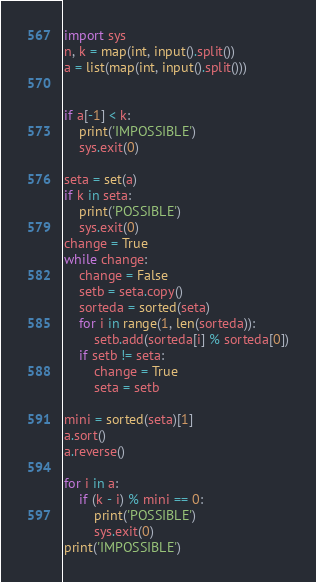Convert code to text. <code><loc_0><loc_0><loc_500><loc_500><_Python_>import sys
n, k = map(int, input().split())
a = list(map(int, input().split()))


if a[-1] < k:
    print('IMPOSSIBLE')
    sys.exit(0)

seta = set(a)
if k in seta:
    print('POSSIBLE')
    sys.exit(0)
change = True
while change:
    change = False
    setb = seta.copy()
    sorteda = sorted(seta)
    for i in range(1, len(sorteda)):
        setb.add(sorteda[i] % sorteda[0])
    if setb != seta:
        change = True
        seta = setb

mini = sorted(seta)[1]
a.sort()
a.reverse()

for i in a:
    if (k - i) % mini == 0:
        print('POSSIBLE')
        sys.exit(0)
print('IMPOSSIBLE')</code> 